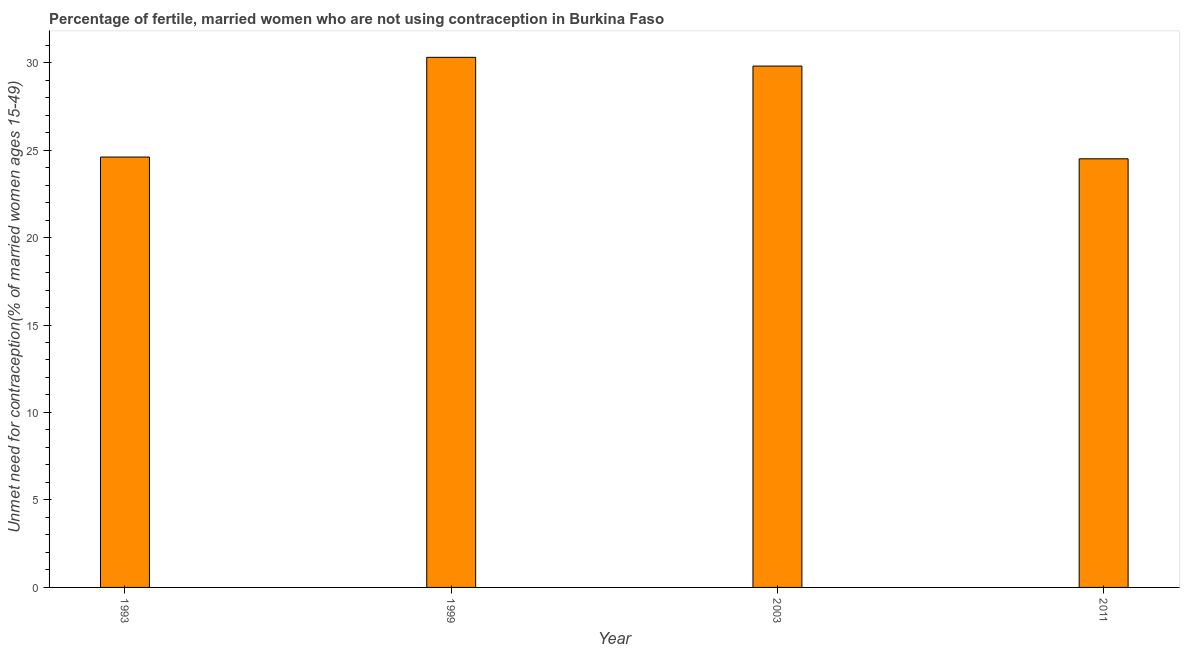Does the graph contain any zero values?
Make the answer very short. No. What is the title of the graph?
Ensure brevity in your answer.  Percentage of fertile, married women who are not using contraception in Burkina Faso. What is the label or title of the Y-axis?
Make the answer very short.  Unmet need for contraception(% of married women ages 15-49). What is the number of married women who are not using contraception in 2003?
Ensure brevity in your answer.  29.8. Across all years, what is the maximum number of married women who are not using contraception?
Your answer should be very brief. 30.3. In which year was the number of married women who are not using contraception maximum?
Ensure brevity in your answer.  1999. In which year was the number of married women who are not using contraception minimum?
Your answer should be very brief. 2011. What is the sum of the number of married women who are not using contraception?
Provide a succinct answer. 109.2. What is the difference between the number of married women who are not using contraception in 2003 and 2011?
Provide a short and direct response. 5.3. What is the average number of married women who are not using contraception per year?
Offer a terse response. 27.3. What is the median number of married women who are not using contraception?
Give a very brief answer. 27.2. In how many years, is the number of married women who are not using contraception greater than 25 %?
Keep it short and to the point. 2. What is the ratio of the number of married women who are not using contraception in 1993 to that in 1999?
Provide a succinct answer. 0.81. Is the sum of the number of married women who are not using contraception in 1999 and 2011 greater than the maximum number of married women who are not using contraception across all years?
Your answer should be compact. Yes. In how many years, is the number of married women who are not using contraception greater than the average number of married women who are not using contraception taken over all years?
Give a very brief answer. 2. What is the difference between two consecutive major ticks on the Y-axis?
Keep it short and to the point. 5. What is the  Unmet need for contraception(% of married women ages 15-49) of 1993?
Your answer should be compact. 24.6. What is the  Unmet need for contraception(% of married women ages 15-49) in 1999?
Your answer should be very brief. 30.3. What is the  Unmet need for contraception(% of married women ages 15-49) in 2003?
Ensure brevity in your answer.  29.8. What is the  Unmet need for contraception(% of married women ages 15-49) in 2011?
Your answer should be very brief. 24.5. What is the difference between the  Unmet need for contraception(% of married women ages 15-49) in 1993 and 1999?
Provide a short and direct response. -5.7. What is the difference between the  Unmet need for contraception(% of married women ages 15-49) in 1993 and 2011?
Offer a very short reply. 0.1. What is the difference between the  Unmet need for contraception(% of married women ages 15-49) in 1999 and 2011?
Offer a very short reply. 5.8. What is the difference between the  Unmet need for contraception(% of married women ages 15-49) in 2003 and 2011?
Offer a terse response. 5.3. What is the ratio of the  Unmet need for contraception(% of married women ages 15-49) in 1993 to that in 1999?
Make the answer very short. 0.81. What is the ratio of the  Unmet need for contraception(% of married women ages 15-49) in 1993 to that in 2003?
Keep it short and to the point. 0.83. What is the ratio of the  Unmet need for contraception(% of married women ages 15-49) in 1993 to that in 2011?
Your answer should be very brief. 1. What is the ratio of the  Unmet need for contraception(% of married women ages 15-49) in 1999 to that in 2003?
Provide a short and direct response. 1.02. What is the ratio of the  Unmet need for contraception(% of married women ages 15-49) in 1999 to that in 2011?
Keep it short and to the point. 1.24. What is the ratio of the  Unmet need for contraception(% of married women ages 15-49) in 2003 to that in 2011?
Provide a short and direct response. 1.22. 